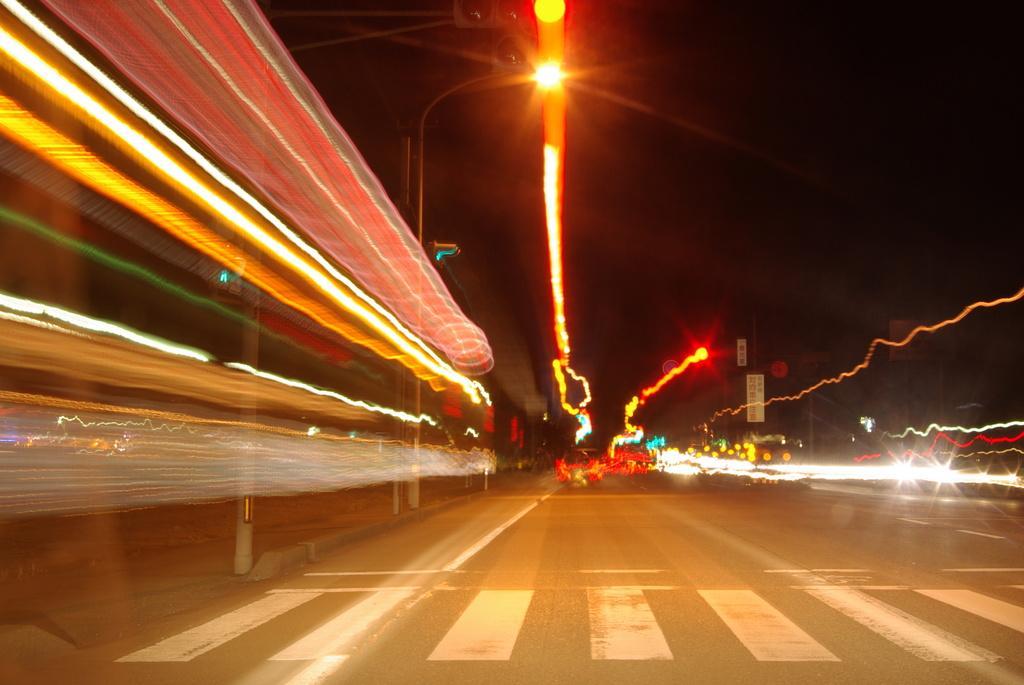Could you give a brief overview of what you see in this image? This picture is clicked outside and seems to be an edited image. In the foreground we can see the zebra crossing and we can see the road. On the left we can see a building like object. In the center we can see the lights, lamp post, text on the boards and many other objects. In the background we can see the sky. 